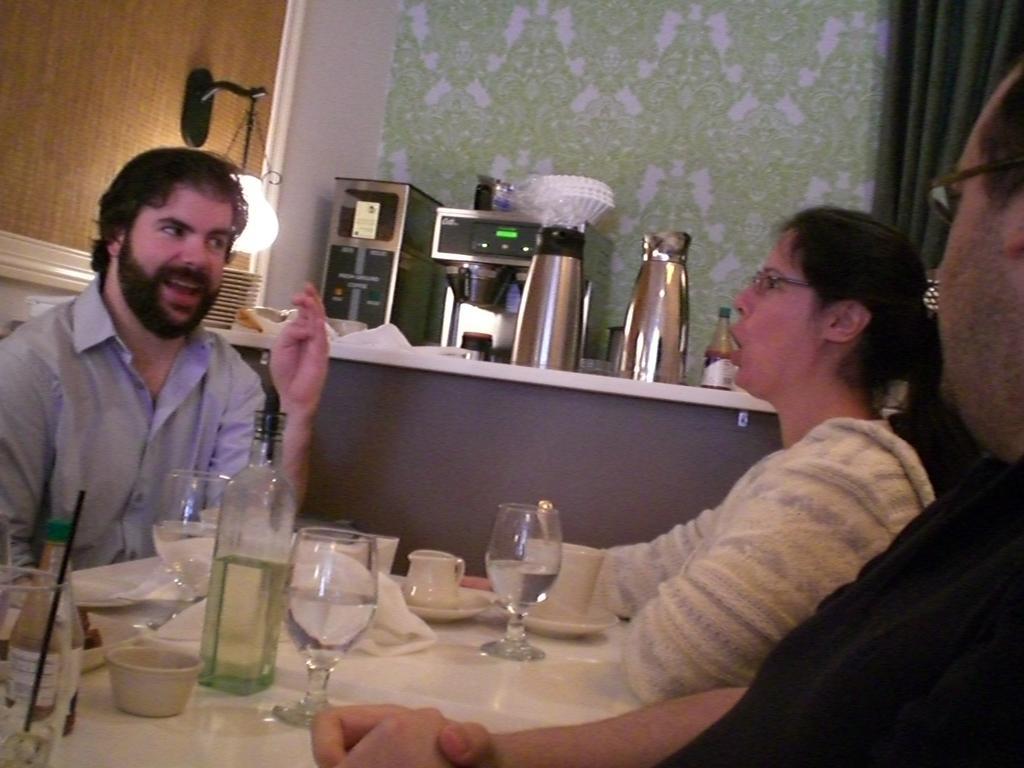Describe this image in one or two sentences. Here in this picture we can see a group of people sitting on chairs with table in front of them having bottles and glasses and bowls and cups all present on the table over there and behind them on the counter top we can see a coffee machine, a couple of flasks and a lamp and other kitchen items present all over there. 